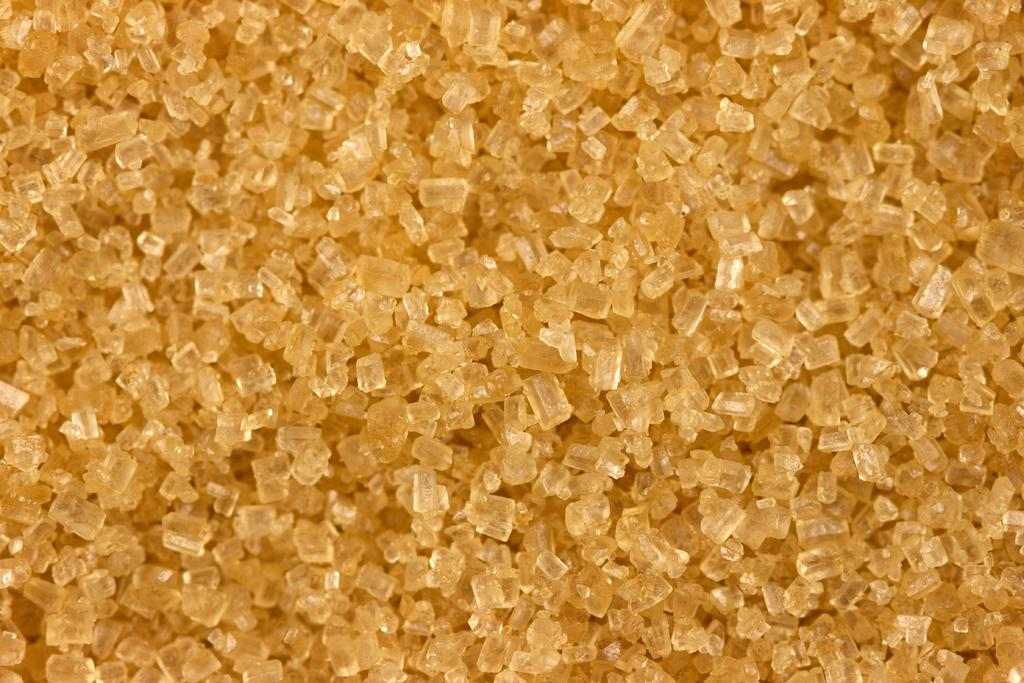What is present in the image related to sweetening food? There is sugar in the image. What type of gold can be seen being tested in the image? There is no gold or testing process present in the image; it only contains sugar. 